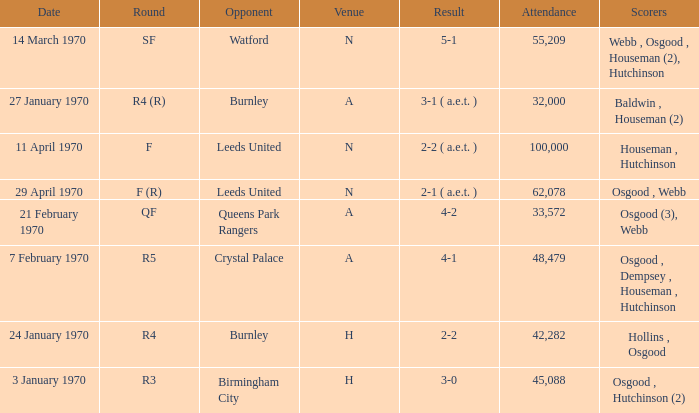What round was the game with a result of 5-1 at N venue? SF. 